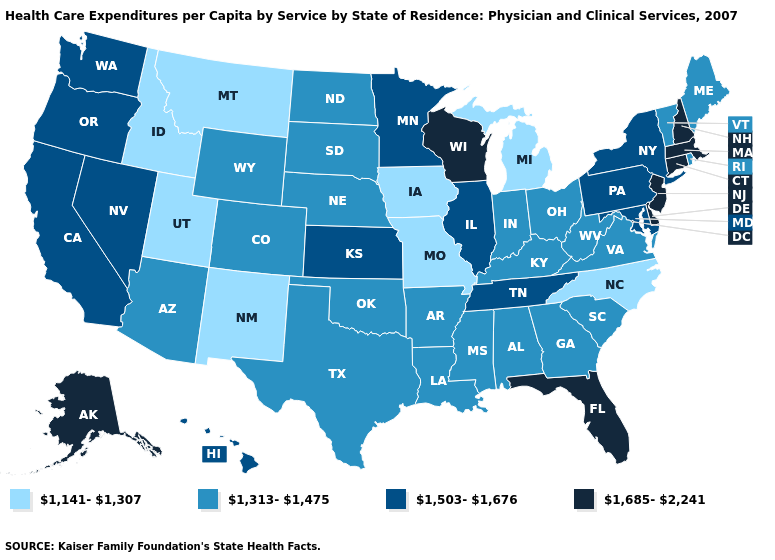Does Florida have a lower value than Virginia?
Short answer required. No. What is the highest value in the MidWest ?
Answer briefly. 1,685-2,241. What is the lowest value in the USA?
Quick response, please. 1,141-1,307. Does Arizona have the lowest value in the USA?
Quick response, please. No. What is the value of Wisconsin?
Short answer required. 1,685-2,241. Is the legend a continuous bar?
Write a very short answer. No. Is the legend a continuous bar?
Concise answer only. No. Is the legend a continuous bar?
Concise answer only. No. Among the states that border Wyoming , does Montana have the lowest value?
Answer briefly. Yes. What is the value of Connecticut?
Quick response, please. 1,685-2,241. What is the value of Minnesota?
Give a very brief answer. 1,503-1,676. Among the states that border Texas , which have the highest value?
Give a very brief answer. Arkansas, Louisiana, Oklahoma. Does New Mexico have a lower value than Montana?
Write a very short answer. No. Does Maryland have the lowest value in the USA?
Short answer required. No. What is the lowest value in the West?
Concise answer only. 1,141-1,307. 